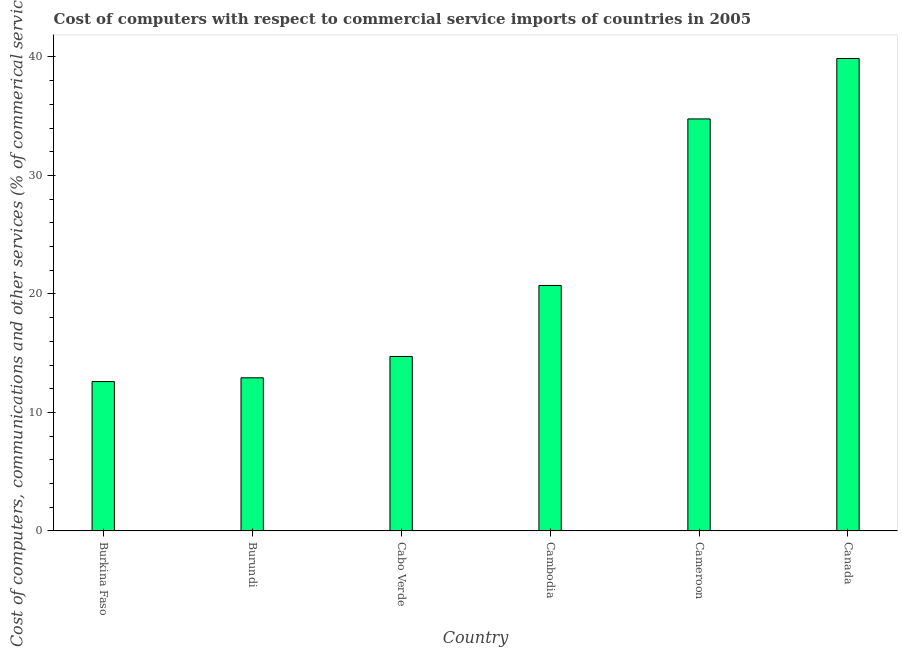Does the graph contain any zero values?
Offer a terse response. No. What is the title of the graph?
Keep it short and to the point. Cost of computers with respect to commercial service imports of countries in 2005. What is the label or title of the X-axis?
Provide a succinct answer. Country. What is the label or title of the Y-axis?
Keep it short and to the point. Cost of computers, communications and other services (% of commerical service exports). What is the cost of communications in Burundi?
Offer a terse response. 12.92. Across all countries, what is the maximum  computer and other services?
Provide a succinct answer. 39.87. Across all countries, what is the minimum  computer and other services?
Your answer should be very brief. 12.61. In which country was the cost of communications maximum?
Offer a very short reply. Canada. In which country was the  computer and other services minimum?
Offer a very short reply. Burkina Faso. What is the sum of the cost of communications?
Ensure brevity in your answer.  135.6. What is the difference between the cost of communications in Cameroon and Canada?
Give a very brief answer. -5.1. What is the average  computer and other services per country?
Your answer should be compact. 22.6. What is the median cost of communications?
Ensure brevity in your answer.  17.72. What is the ratio of the  computer and other services in Cabo Verde to that in Cambodia?
Make the answer very short. 0.71. What is the difference between the highest and the second highest cost of communications?
Your answer should be very brief. 5.1. What is the difference between the highest and the lowest cost of communications?
Your answer should be very brief. 27.26. In how many countries, is the cost of communications greater than the average cost of communications taken over all countries?
Offer a terse response. 2. How many bars are there?
Offer a very short reply. 6. Are all the bars in the graph horizontal?
Offer a very short reply. No. How many countries are there in the graph?
Offer a very short reply. 6. What is the difference between two consecutive major ticks on the Y-axis?
Your response must be concise. 10. Are the values on the major ticks of Y-axis written in scientific E-notation?
Your answer should be compact. No. What is the Cost of computers, communications and other services (% of commerical service exports) in Burkina Faso?
Ensure brevity in your answer.  12.61. What is the Cost of computers, communications and other services (% of commerical service exports) in Burundi?
Offer a terse response. 12.92. What is the Cost of computers, communications and other services (% of commerical service exports) of Cabo Verde?
Offer a very short reply. 14.72. What is the Cost of computers, communications and other services (% of commerical service exports) in Cambodia?
Ensure brevity in your answer.  20.72. What is the Cost of computers, communications and other services (% of commerical service exports) in Cameroon?
Provide a short and direct response. 34.77. What is the Cost of computers, communications and other services (% of commerical service exports) in Canada?
Provide a short and direct response. 39.87. What is the difference between the Cost of computers, communications and other services (% of commerical service exports) in Burkina Faso and Burundi?
Offer a terse response. -0.32. What is the difference between the Cost of computers, communications and other services (% of commerical service exports) in Burkina Faso and Cabo Verde?
Your answer should be very brief. -2.12. What is the difference between the Cost of computers, communications and other services (% of commerical service exports) in Burkina Faso and Cambodia?
Your response must be concise. -8.11. What is the difference between the Cost of computers, communications and other services (% of commerical service exports) in Burkina Faso and Cameroon?
Make the answer very short. -22.16. What is the difference between the Cost of computers, communications and other services (% of commerical service exports) in Burkina Faso and Canada?
Provide a short and direct response. -27.26. What is the difference between the Cost of computers, communications and other services (% of commerical service exports) in Burundi and Cabo Verde?
Give a very brief answer. -1.8. What is the difference between the Cost of computers, communications and other services (% of commerical service exports) in Burundi and Cambodia?
Offer a very short reply. -7.79. What is the difference between the Cost of computers, communications and other services (% of commerical service exports) in Burundi and Cameroon?
Offer a very short reply. -21.85. What is the difference between the Cost of computers, communications and other services (% of commerical service exports) in Burundi and Canada?
Offer a terse response. -26.95. What is the difference between the Cost of computers, communications and other services (% of commerical service exports) in Cabo Verde and Cambodia?
Ensure brevity in your answer.  -5.99. What is the difference between the Cost of computers, communications and other services (% of commerical service exports) in Cabo Verde and Cameroon?
Give a very brief answer. -20.05. What is the difference between the Cost of computers, communications and other services (% of commerical service exports) in Cabo Verde and Canada?
Keep it short and to the point. -25.15. What is the difference between the Cost of computers, communications and other services (% of commerical service exports) in Cambodia and Cameroon?
Make the answer very short. -14.05. What is the difference between the Cost of computers, communications and other services (% of commerical service exports) in Cambodia and Canada?
Provide a succinct answer. -19.15. What is the difference between the Cost of computers, communications and other services (% of commerical service exports) in Cameroon and Canada?
Provide a short and direct response. -5.1. What is the ratio of the Cost of computers, communications and other services (% of commerical service exports) in Burkina Faso to that in Cabo Verde?
Provide a succinct answer. 0.86. What is the ratio of the Cost of computers, communications and other services (% of commerical service exports) in Burkina Faso to that in Cambodia?
Give a very brief answer. 0.61. What is the ratio of the Cost of computers, communications and other services (% of commerical service exports) in Burkina Faso to that in Cameroon?
Your answer should be very brief. 0.36. What is the ratio of the Cost of computers, communications and other services (% of commerical service exports) in Burkina Faso to that in Canada?
Your answer should be compact. 0.32. What is the ratio of the Cost of computers, communications and other services (% of commerical service exports) in Burundi to that in Cabo Verde?
Provide a succinct answer. 0.88. What is the ratio of the Cost of computers, communications and other services (% of commerical service exports) in Burundi to that in Cambodia?
Give a very brief answer. 0.62. What is the ratio of the Cost of computers, communications and other services (% of commerical service exports) in Burundi to that in Cameroon?
Your response must be concise. 0.37. What is the ratio of the Cost of computers, communications and other services (% of commerical service exports) in Burundi to that in Canada?
Offer a terse response. 0.32. What is the ratio of the Cost of computers, communications and other services (% of commerical service exports) in Cabo Verde to that in Cambodia?
Provide a succinct answer. 0.71. What is the ratio of the Cost of computers, communications and other services (% of commerical service exports) in Cabo Verde to that in Cameroon?
Provide a succinct answer. 0.42. What is the ratio of the Cost of computers, communications and other services (% of commerical service exports) in Cabo Verde to that in Canada?
Offer a very short reply. 0.37. What is the ratio of the Cost of computers, communications and other services (% of commerical service exports) in Cambodia to that in Cameroon?
Ensure brevity in your answer.  0.6. What is the ratio of the Cost of computers, communications and other services (% of commerical service exports) in Cambodia to that in Canada?
Offer a very short reply. 0.52. What is the ratio of the Cost of computers, communications and other services (% of commerical service exports) in Cameroon to that in Canada?
Your answer should be compact. 0.87. 